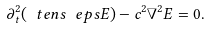Convert formula to latex. <formula><loc_0><loc_0><loc_500><loc_500>\partial _ { t } ^ { 2 } ( \ t e n s \ e p s E ) - c ^ { 2 } \nabla ^ { 2 } E = 0 .</formula> 